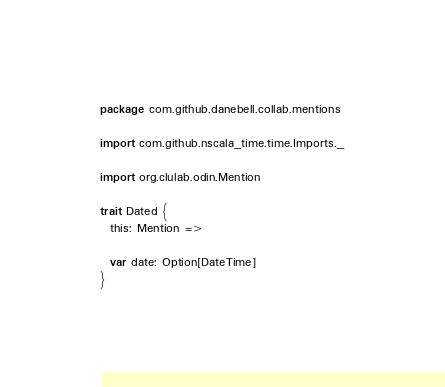Convert code to text. <code><loc_0><loc_0><loc_500><loc_500><_Scala_>package com.github.danebell.collab.mentions

import com.github.nscala_time.time.Imports._

import org.clulab.odin.Mention

trait Dated {
  this: Mention =>

  var date: Option[DateTime]
}</code> 